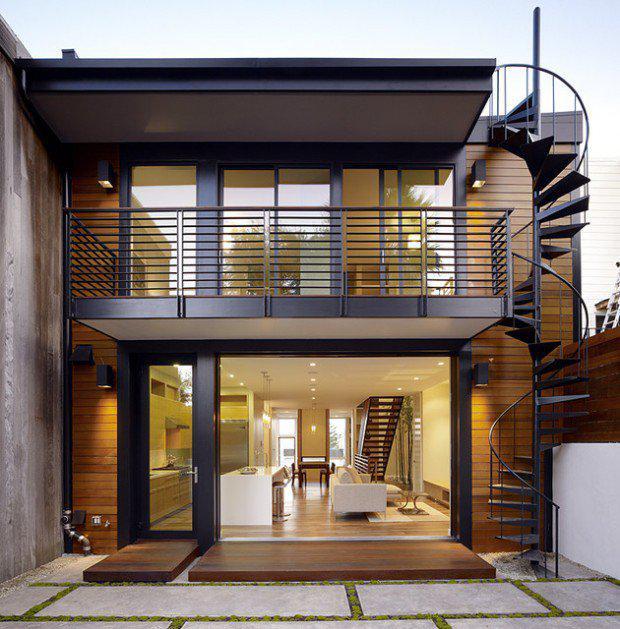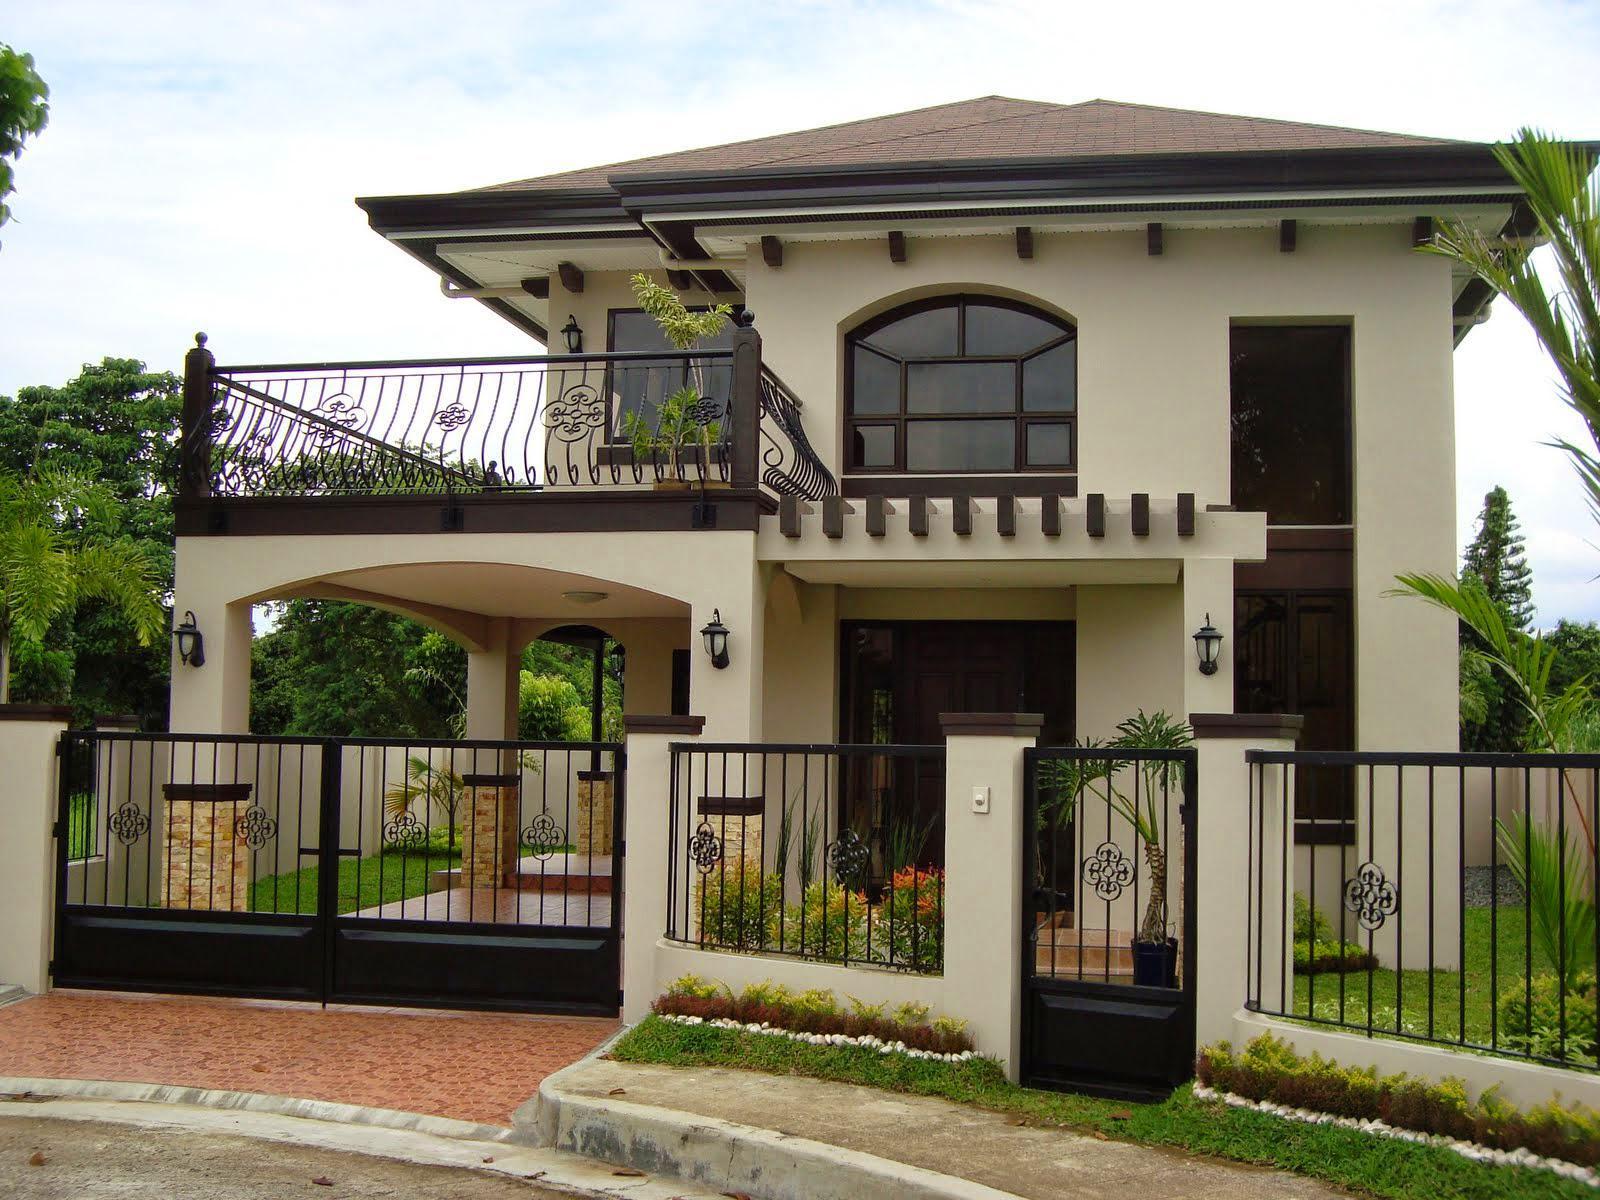The first image is the image on the left, the second image is the image on the right. Assess this claim about the two images: "The left and right image contains the same number of stories on a single home.". Correct or not? Answer yes or no. Yes. The first image is the image on the left, the second image is the image on the right. Considering the images on both sides, is "One of the balconies has a horizontal design balcony railing." valid? Answer yes or no. Yes. 